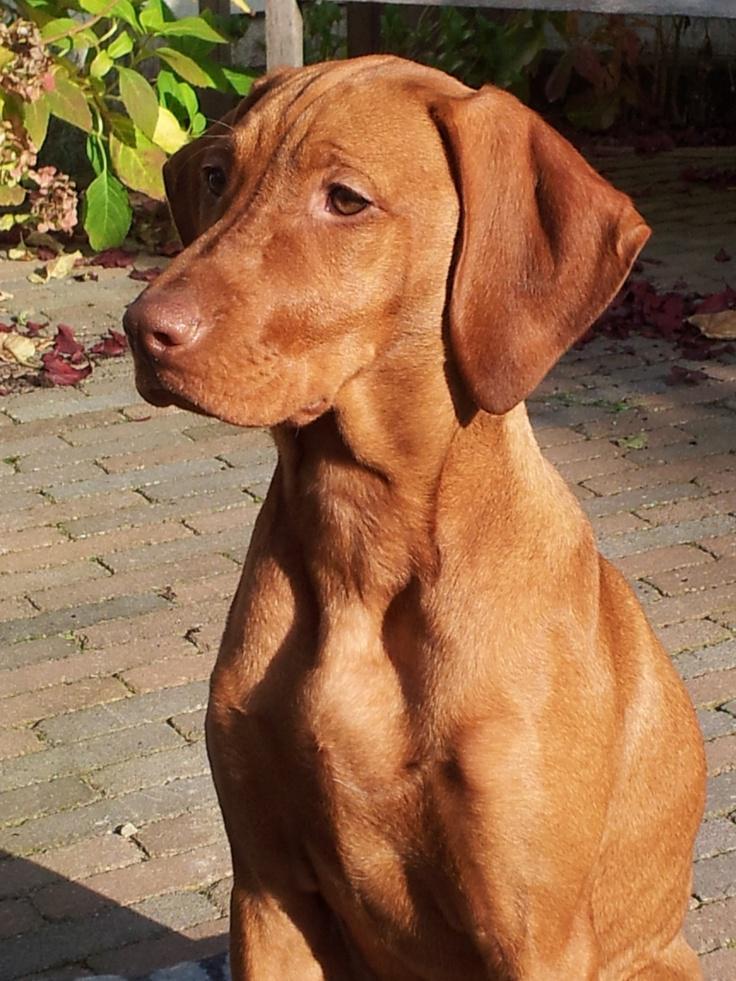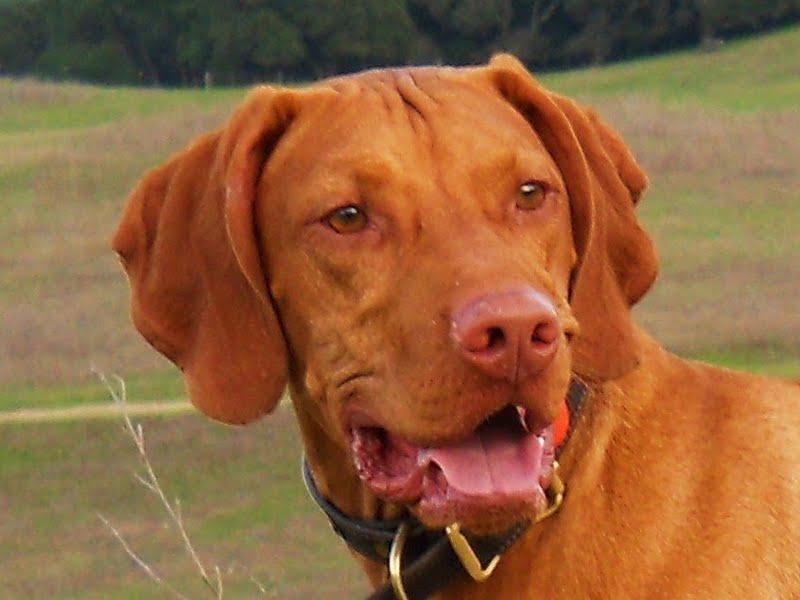The first image is the image on the left, the second image is the image on the right. For the images displayed, is the sentence "One dog is outdoors, while the other dog is indoors." factually correct? Answer yes or no. No. The first image is the image on the left, the second image is the image on the right. Considering the images on both sides, is "The dog in the right image is wearing a black collar." valid? Answer yes or no. Yes. 